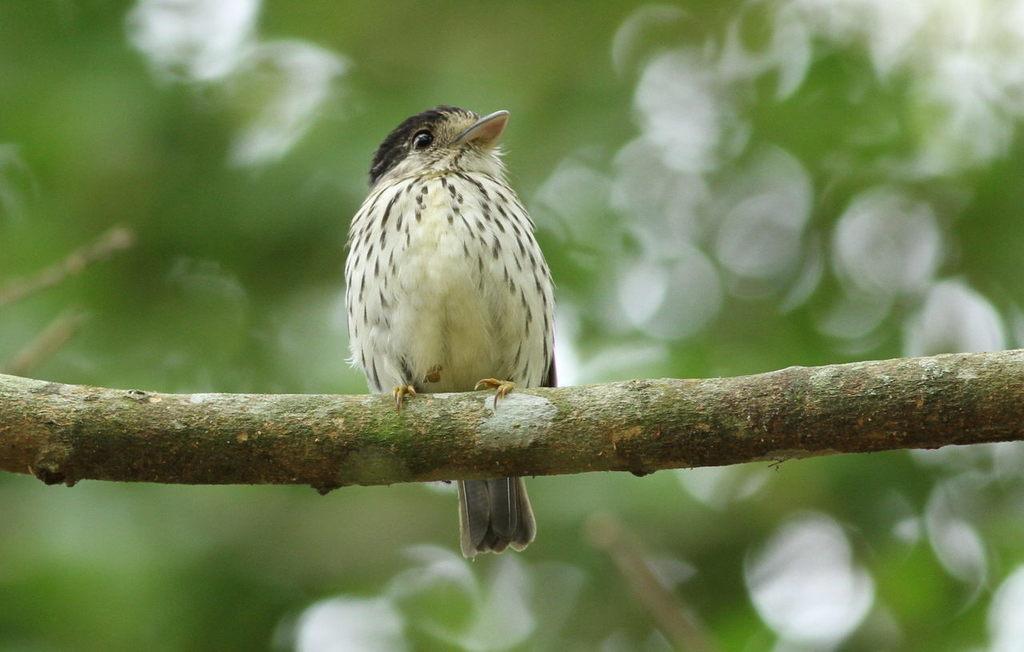Can you describe this image briefly? As we can see in the image in the front there is a bird and the background is blurred. 